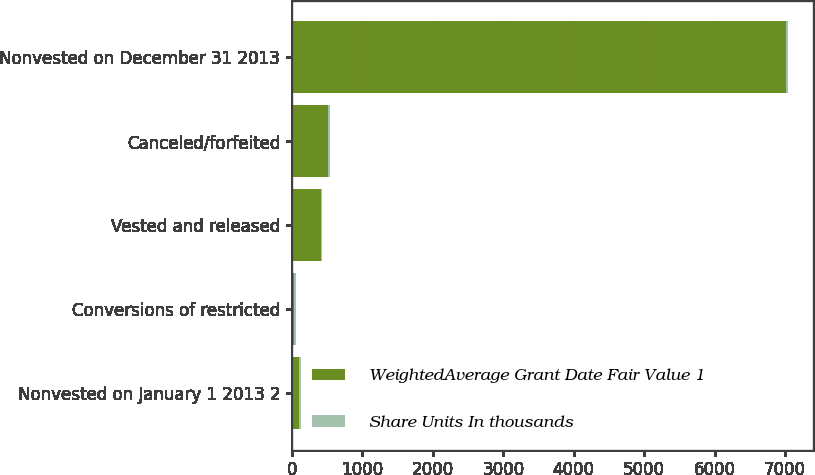Convert chart to OTSL. <chart><loc_0><loc_0><loc_500><loc_500><stacked_bar_chart><ecel><fcel>Nonvested on January 1 2013 2<fcel>Conversions of restricted<fcel>Vested and released<fcel>Canceled/forfeited<fcel>Nonvested on December 31 2013<nl><fcel>WeightedAverage Grant Date Fair Value 1<fcel>98<fcel>26.54<fcel>406<fcel>508<fcel>7014<nl><fcel>Share Units In thousands<fcel>26.54<fcel>25.17<fcel>25.52<fcel>25.17<fcel>25.17<nl></chart> 